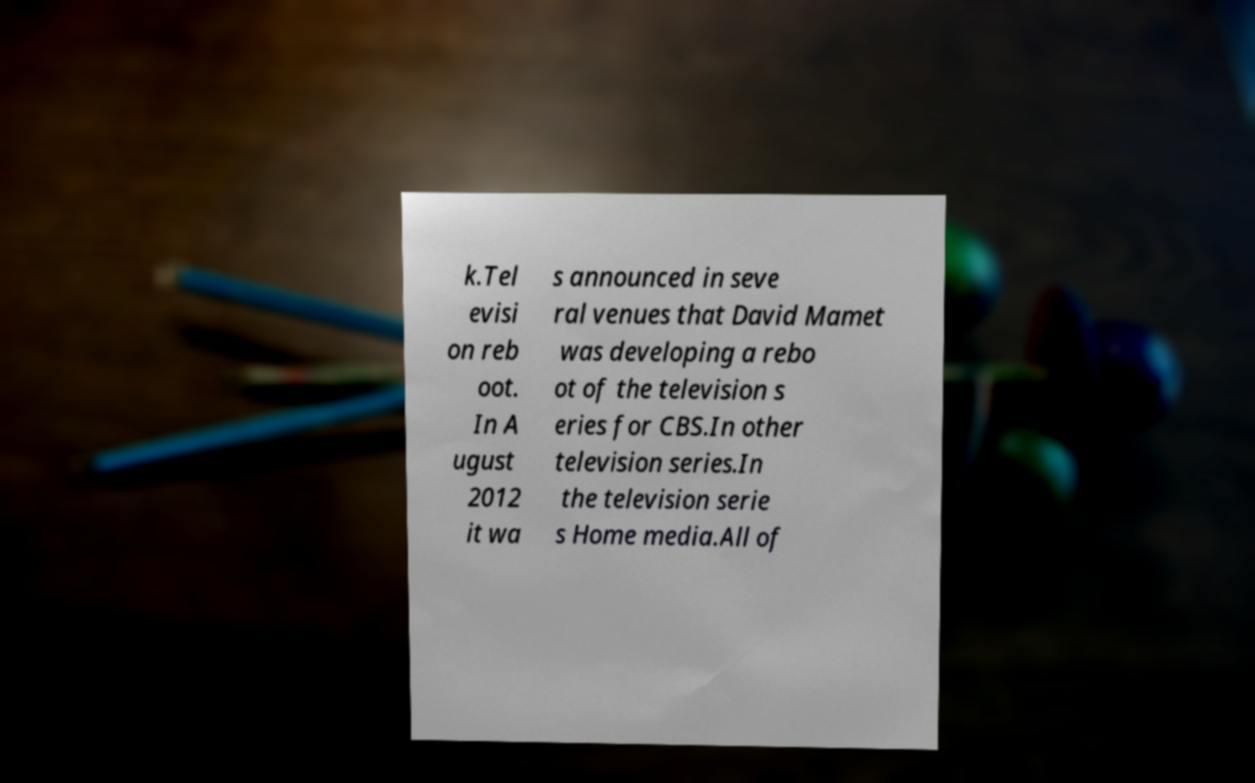Please read and relay the text visible in this image. What does it say? k.Tel evisi on reb oot. In A ugust 2012 it wa s announced in seve ral venues that David Mamet was developing a rebo ot of the television s eries for CBS.In other television series.In the television serie s Home media.All of 